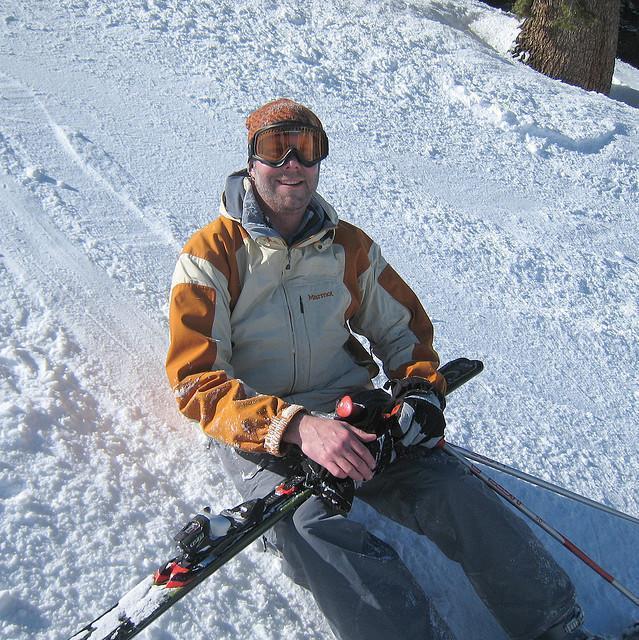How many gloves is he wearing?
Give a very brief answer. 1. How many people are there?
Give a very brief answer. 1. 